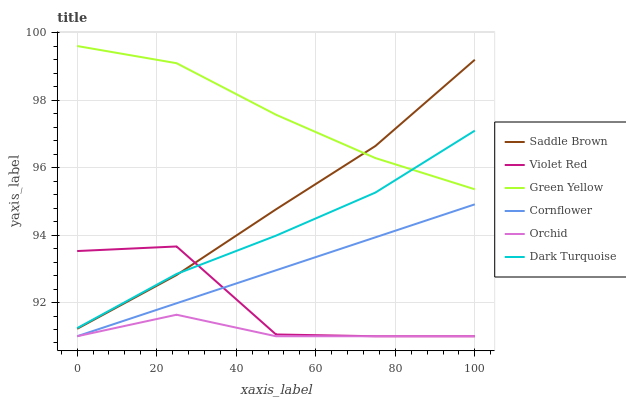Does Orchid have the minimum area under the curve?
Answer yes or no. Yes. Does Green Yellow have the maximum area under the curve?
Answer yes or no. Yes. Does Violet Red have the minimum area under the curve?
Answer yes or no. No. Does Violet Red have the maximum area under the curve?
Answer yes or no. No. Is Cornflower the smoothest?
Answer yes or no. Yes. Is Violet Red the roughest?
Answer yes or no. Yes. Is Dark Turquoise the smoothest?
Answer yes or no. No. Is Dark Turquoise the roughest?
Answer yes or no. No. Does Cornflower have the lowest value?
Answer yes or no. Yes. Does Dark Turquoise have the lowest value?
Answer yes or no. No. Does Green Yellow have the highest value?
Answer yes or no. Yes. Does Violet Red have the highest value?
Answer yes or no. No. Is Orchid less than Green Yellow?
Answer yes or no. Yes. Is Dark Turquoise greater than Orchid?
Answer yes or no. Yes. Does Violet Red intersect Saddle Brown?
Answer yes or no. Yes. Is Violet Red less than Saddle Brown?
Answer yes or no. No. Is Violet Red greater than Saddle Brown?
Answer yes or no. No. Does Orchid intersect Green Yellow?
Answer yes or no. No. 